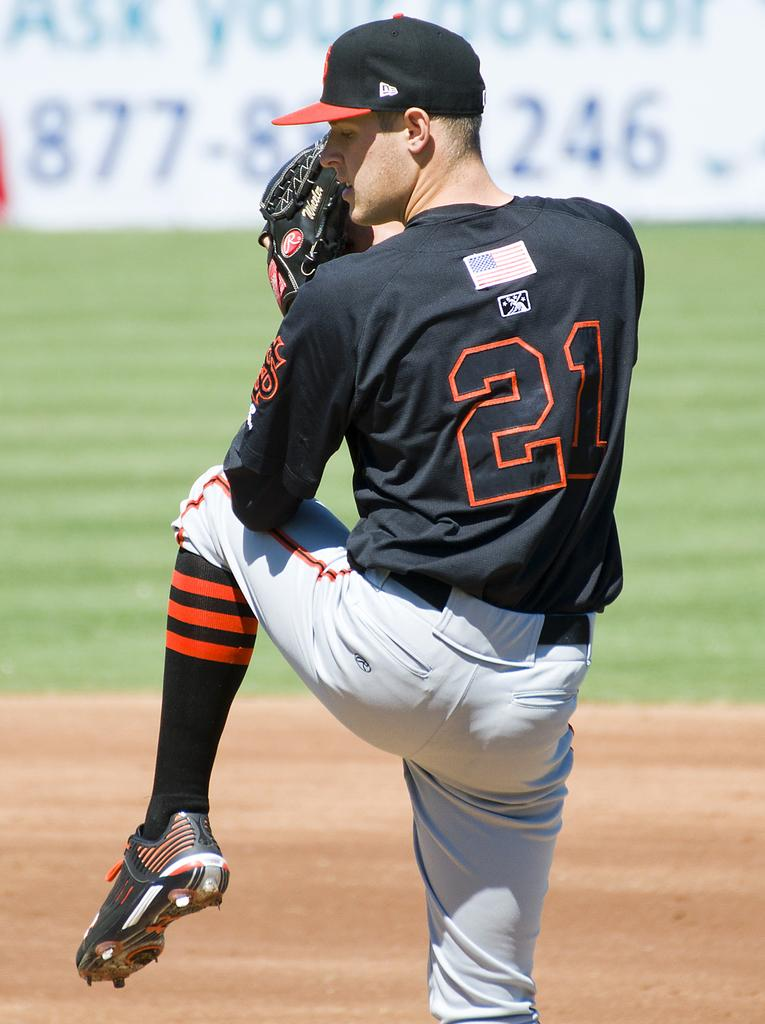<image>
Give a short and clear explanation of the subsequent image. Number 21 is about to pitch the ball, with his leg in the air. 